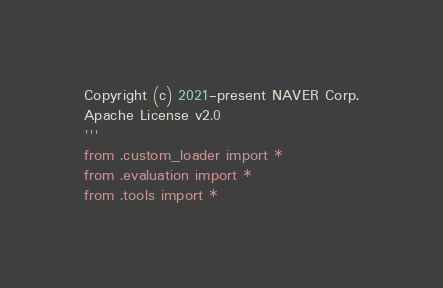Convert code to text. <code><loc_0><loc_0><loc_500><loc_500><_Python_>Copyright (c) 2021-present NAVER Corp.
Apache License v2.0
'''
from .custom_loader import *
from .evaluation import *
from .tools import *
</code> 